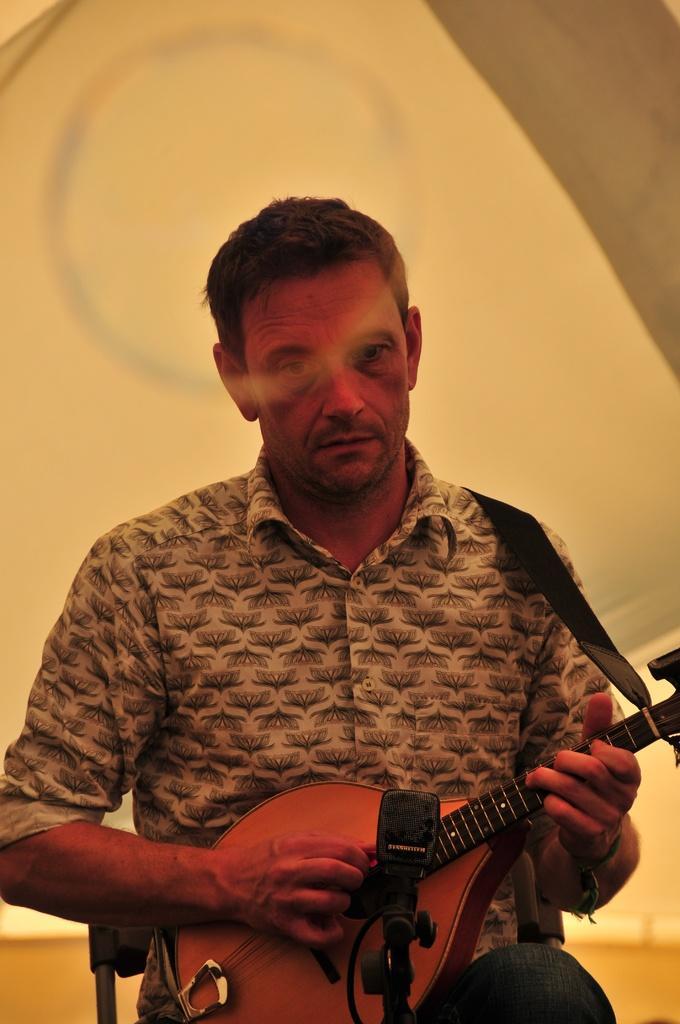Please provide a concise description of this image. In the picture, man is sitting he is playing a musical instrument,he wore it around his shoulder, he is wearing flower design shirt the background is cream color. 